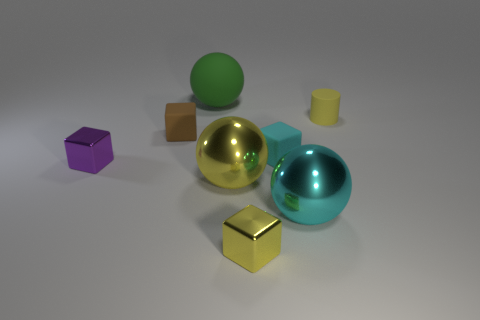What material is the big sphere that is the same color as the cylinder?
Offer a very short reply. Metal. Do the tiny yellow thing that is behind the tiny purple metal object and the rubber thing that is left of the large green rubber sphere have the same shape?
Ensure brevity in your answer.  No. There is a yellow sphere that is the same size as the green thing; what material is it?
Offer a terse response. Metal. Is the material of the small thing to the left of the brown cube the same as the small block that is right of the small yellow shiny cube?
Your response must be concise. No. The yellow object that is the same size as the green sphere is what shape?
Give a very brief answer. Sphere. What number of other things are there of the same color as the big rubber ball?
Make the answer very short. 0. The big thing that is behind the rubber cylinder is what color?
Your response must be concise. Green. What number of other things are made of the same material as the green thing?
Offer a terse response. 3. Is the number of large green balls that are in front of the large green object greater than the number of small cylinders that are to the right of the small rubber cylinder?
Offer a very short reply. No. There is a small yellow cylinder; what number of rubber cylinders are on the right side of it?
Make the answer very short. 0. 